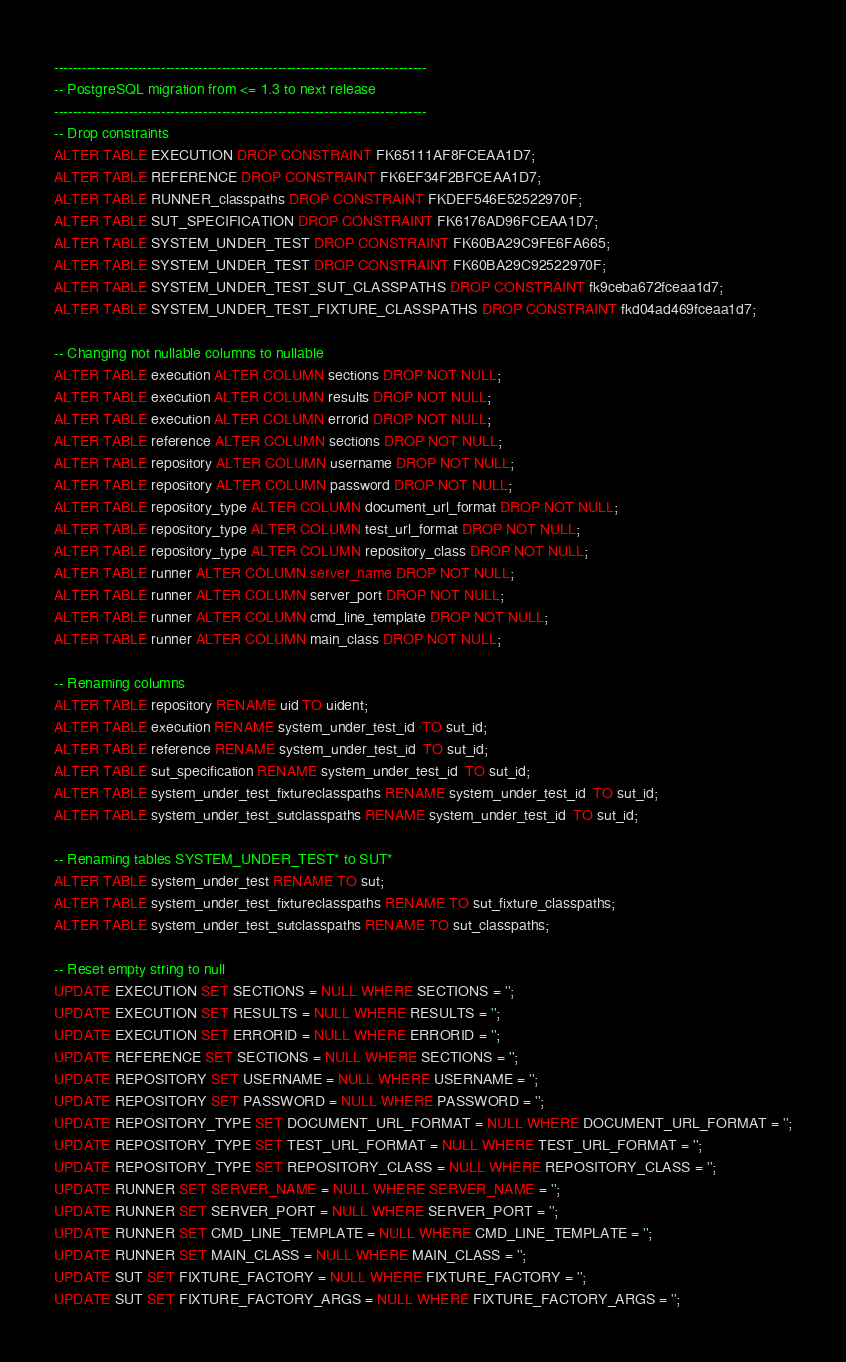<code> <loc_0><loc_0><loc_500><loc_500><_SQL_>--------------------------------------------------------------------------------
-- PostgreSQL migration from <= 1.3 to next release
--------------------------------------------------------------------------------
-- Drop constraints 
ALTER TABLE EXECUTION DROP CONSTRAINT FK65111AF8FCEAA1D7;
ALTER TABLE REFERENCE DROP CONSTRAINT FK6EF34F2BFCEAA1D7;
ALTER TABLE RUNNER_classpaths DROP CONSTRAINT FKDEF546E52522970F;
ALTER TABLE SUT_SPECIFICATION DROP CONSTRAINT FK6176AD96FCEAA1D7;
ALTER TABLE SYSTEM_UNDER_TEST DROP CONSTRAINT FK60BA29C9FE6FA665;
ALTER TABLE SYSTEM_UNDER_TEST DROP CONSTRAINT FK60BA29C92522970F;
ALTER TABLE SYSTEM_UNDER_TEST_SUT_CLASSPATHS DROP CONSTRAINT fk9ceba672fceaa1d7;
ALTER TABLE SYSTEM_UNDER_TEST_FIXTURE_CLASSPATHS DROP CONSTRAINT fkd04ad469fceaa1d7;

-- Changing not nullable columns to nullable
ALTER TABLE execution ALTER COLUMN sections DROP NOT NULL;
ALTER TABLE execution ALTER COLUMN results DROP NOT NULL;
ALTER TABLE execution ALTER COLUMN errorid DROP NOT NULL;
ALTER TABLE reference ALTER COLUMN sections DROP NOT NULL;
ALTER TABLE repository ALTER COLUMN username DROP NOT NULL;
ALTER TABLE repository ALTER COLUMN password DROP NOT NULL;
ALTER TABLE repository_type ALTER COLUMN document_url_format DROP NOT NULL;
ALTER TABLE repository_type ALTER COLUMN test_url_format DROP NOT NULL;
ALTER TABLE repository_type ALTER COLUMN repository_class DROP NOT NULL;
ALTER TABLE runner ALTER COLUMN server_name DROP NOT NULL;
ALTER TABLE runner ALTER COLUMN server_port DROP NOT NULL;
ALTER TABLE runner ALTER COLUMN cmd_line_template DROP NOT NULL;
ALTER TABLE runner ALTER COLUMN main_class DROP NOT NULL;

-- Renaming columns
ALTER TABLE repository RENAME uid TO uident;
ALTER TABLE execution RENAME system_under_test_id  TO sut_id;
ALTER TABLE reference RENAME system_under_test_id  TO sut_id;
ALTER TABLE sut_specification RENAME system_under_test_id  TO sut_id;
ALTER TABLE system_under_test_fixtureclasspaths RENAME system_under_test_id  TO sut_id;
ALTER TABLE system_under_test_sutclasspaths RENAME system_under_test_id  TO sut_id;

-- Renaming tables SYSTEM_UNDER_TEST* to SUT*
ALTER TABLE system_under_test RENAME TO sut;
ALTER TABLE system_under_test_fixtureclasspaths RENAME TO sut_fixture_classpaths;
ALTER TABLE system_under_test_sutclasspaths RENAME TO sut_classpaths;

-- Reset empty string to null
UPDATE EXECUTION SET SECTIONS = NULL WHERE SECTIONS = '';
UPDATE EXECUTION SET RESULTS = NULL WHERE RESULTS = '';
UPDATE EXECUTION SET ERRORID = NULL WHERE ERRORID = '';
UPDATE REFERENCE SET SECTIONS = NULL WHERE SECTIONS = '';
UPDATE REPOSITORY SET USERNAME = NULL WHERE USERNAME = '';
UPDATE REPOSITORY SET PASSWORD = NULL WHERE PASSWORD = '';
UPDATE REPOSITORY_TYPE SET DOCUMENT_URL_FORMAT = NULL WHERE DOCUMENT_URL_FORMAT = '';
UPDATE REPOSITORY_TYPE SET TEST_URL_FORMAT = NULL WHERE TEST_URL_FORMAT = '';
UPDATE REPOSITORY_TYPE SET REPOSITORY_CLASS = NULL WHERE REPOSITORY_CLASS = '';
UPDATE RUNNER SET SERVER_NAME = NULL WHERE SERVER_NAME = '';
UPDATE RUNNER SET SERVER_PORT = NULL WHERE SERVER_PORT = '';
UPDATE RUNNER SET CMD_LINE_TEMPLATE = NULL WHERE CMD_LINE_TEMPLATE = '';
UPDATE RUNNER SET MAIN_CLASS = NULL WHERE MAIN_CLASS = '';
UPDATE SUT SET FIXTURE_FACTORY = NULL WHERE FIXTURE_FACTORY = '';
UPDATE SUT SET FIXTURE_FACTORY_ARGS = NULL WHERE FIXTURE_FACTORY_ARGS = '';

</code> 